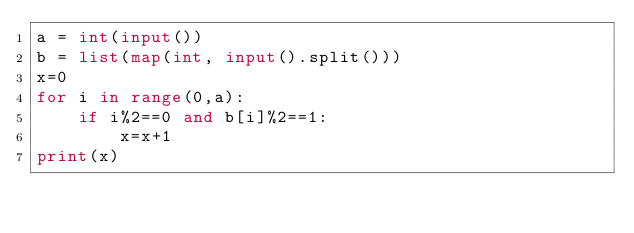<code> <loc_0><loc_0><loc_500><loc_500><_Python_>a = int(input())
b = list(map(int, input().split()))
x=0
for i in range(0,a):
    if i%2==0 and b[i]%2==1:
        x=x+1
print(x)</code> 